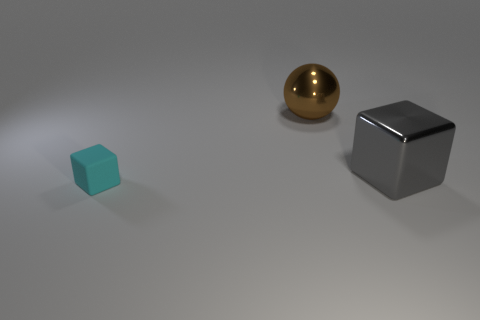Add 3 gray matte cubes. How many objects exist? 6 Subtract all cubes. How many objects are left? 1 Subtract 0 gray cylinders. How many objects are left? 3 Subtract all small brown matte objects. Subtract all tiny matte things. How many objects are left? 2 Add 1 brown metal spheres. How many brown metal spheres are left? 2 Add 2 cyan matte blocks. How many cyan matte blocks exist? 3 